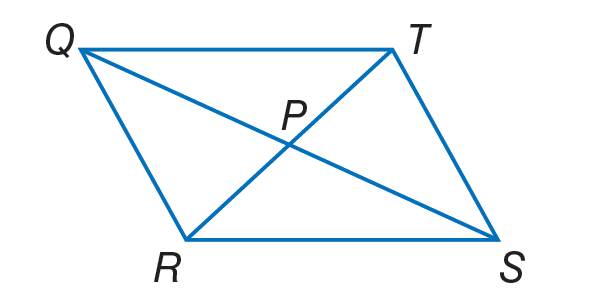Question: If T P = 4 x + 2, Q P = 2 y - 6, P S = 5 y - 12, and P R = 6 x - 4, find x so that the quadrilateral is a parallelogram.
Choices:
A. 0
B. 3
C. 5
D. 14
Answer with the letter. Answer: B Question: If T P = 4 x + 2, Q P = 2 y - 6, P S = 5 y - 12, and P R = 6 x - 4, find y so that the quadrilateral is a parallelogram.
Choices:
A. 2
B. 5
C. 12
D. 20
Answer with the letter. Answer: A 